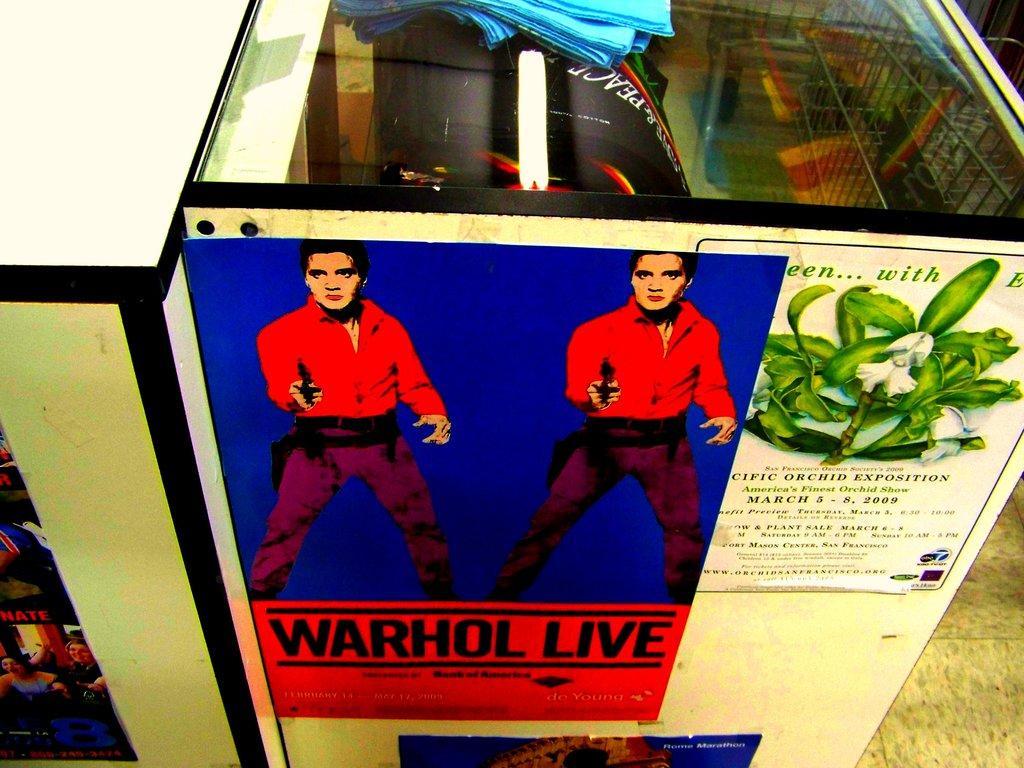How would you summarize this image in a sentence or two? In this image there are two tables with posters on it. Inside the table there are some objects. At the bottom of the image there is a floor. 